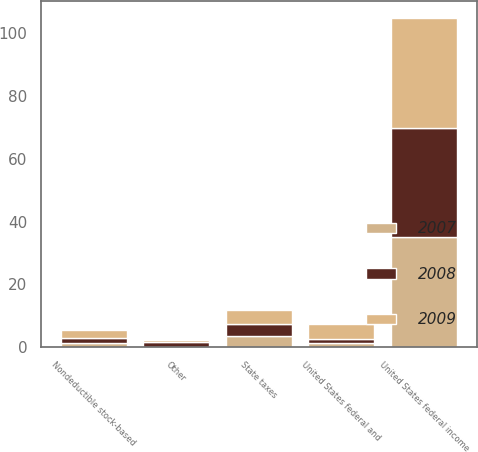Convert chart. <chart><loc_0><loc_0><loc_500><loc_500><stacked_bar_chart><ecel><fcel>United States federal income<fcel>State taxes<fcel>Nondeductible stock-based<fcel>United States federal and<fcel>Other<nl><fcel>2007<fcel>35<fcel>3.7<fcel>1.2<fcel>1.4<fcel>0.1<nl><fcel>2008<fcel>35<fcel>3.8<fcel>1.6<fcel>1.3<fcel>1.6<nl><fcel>2009<fcel>35<fcel>4.4<fcel>2.7<fcel>4.6<fcel>0.7<nl></chart> 